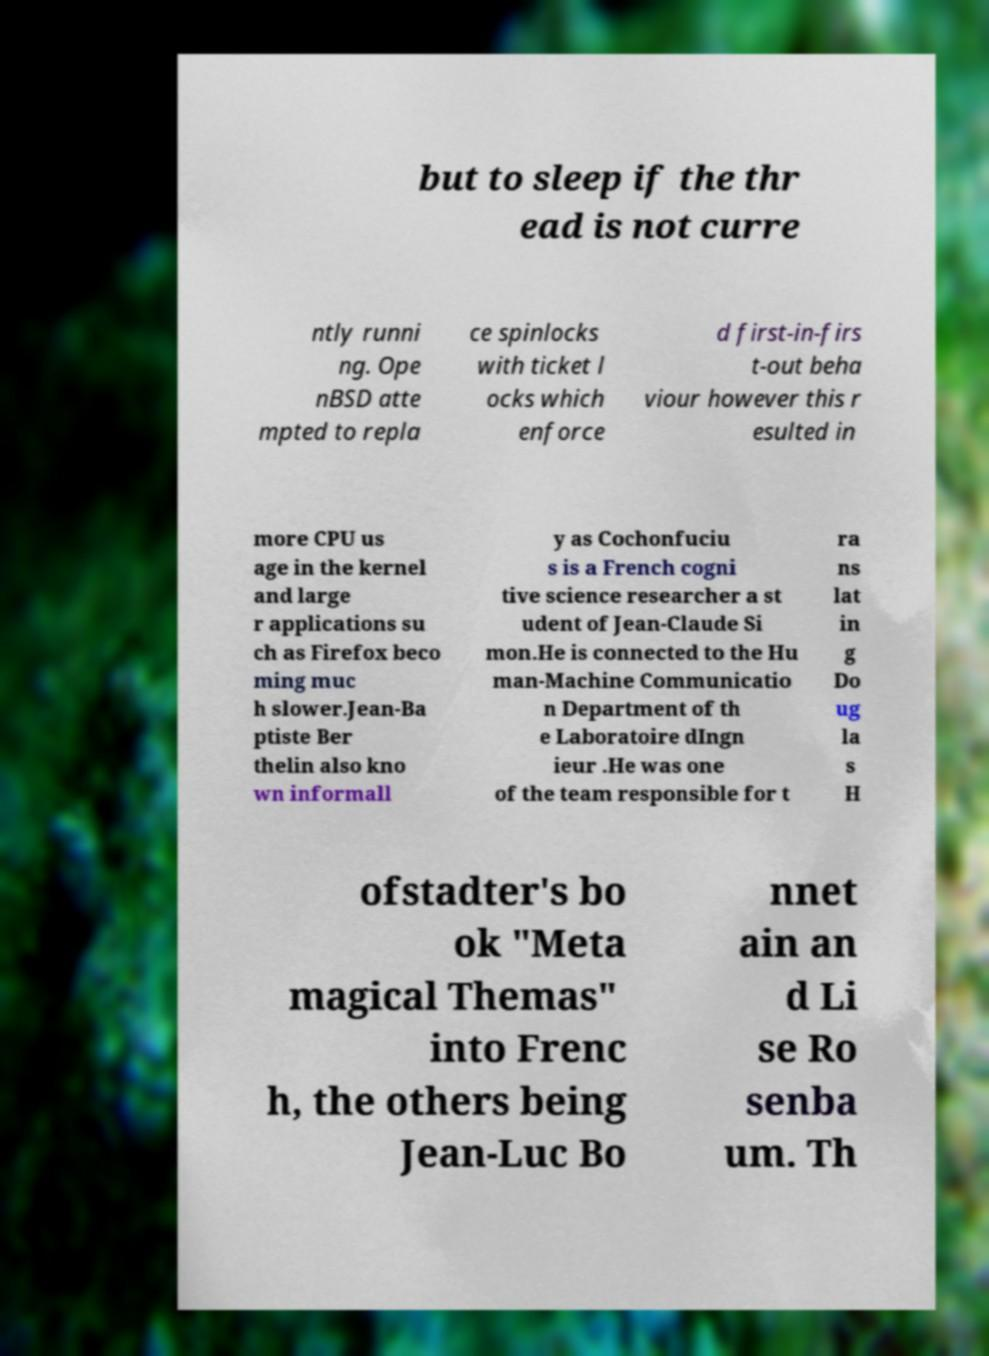Could you assist in decoding the text presented in this image and type it out clearly? but to sleep if the thr ead is not curre ntly runni ng. Ope nBSD atte mpted to repla ce spinlocks with ticket l ocks which enforce d first-in-firs t-out beha viour however this r esulted in more CPU us age in the kernel and large r applications su ch as Firefox beco ming muc h slower.Jean-Ba ptiste Ber thelin also kno wn informall y as Cochonfuciu s is a French cogni tive science researcher a st udent of Jean-Claude Si mon.He is connected to the Hu man-Machine Communicatio n Department of th e Laboratoire dIngn ieur .He was one of the team responsible for t ra ns lat in g Do ug la s H ofstadter's bo ok "Meta magical Themas" into Frenc h, the others being Jean-Luc Bo nnet ain an d Li se Ro senba um. Th 